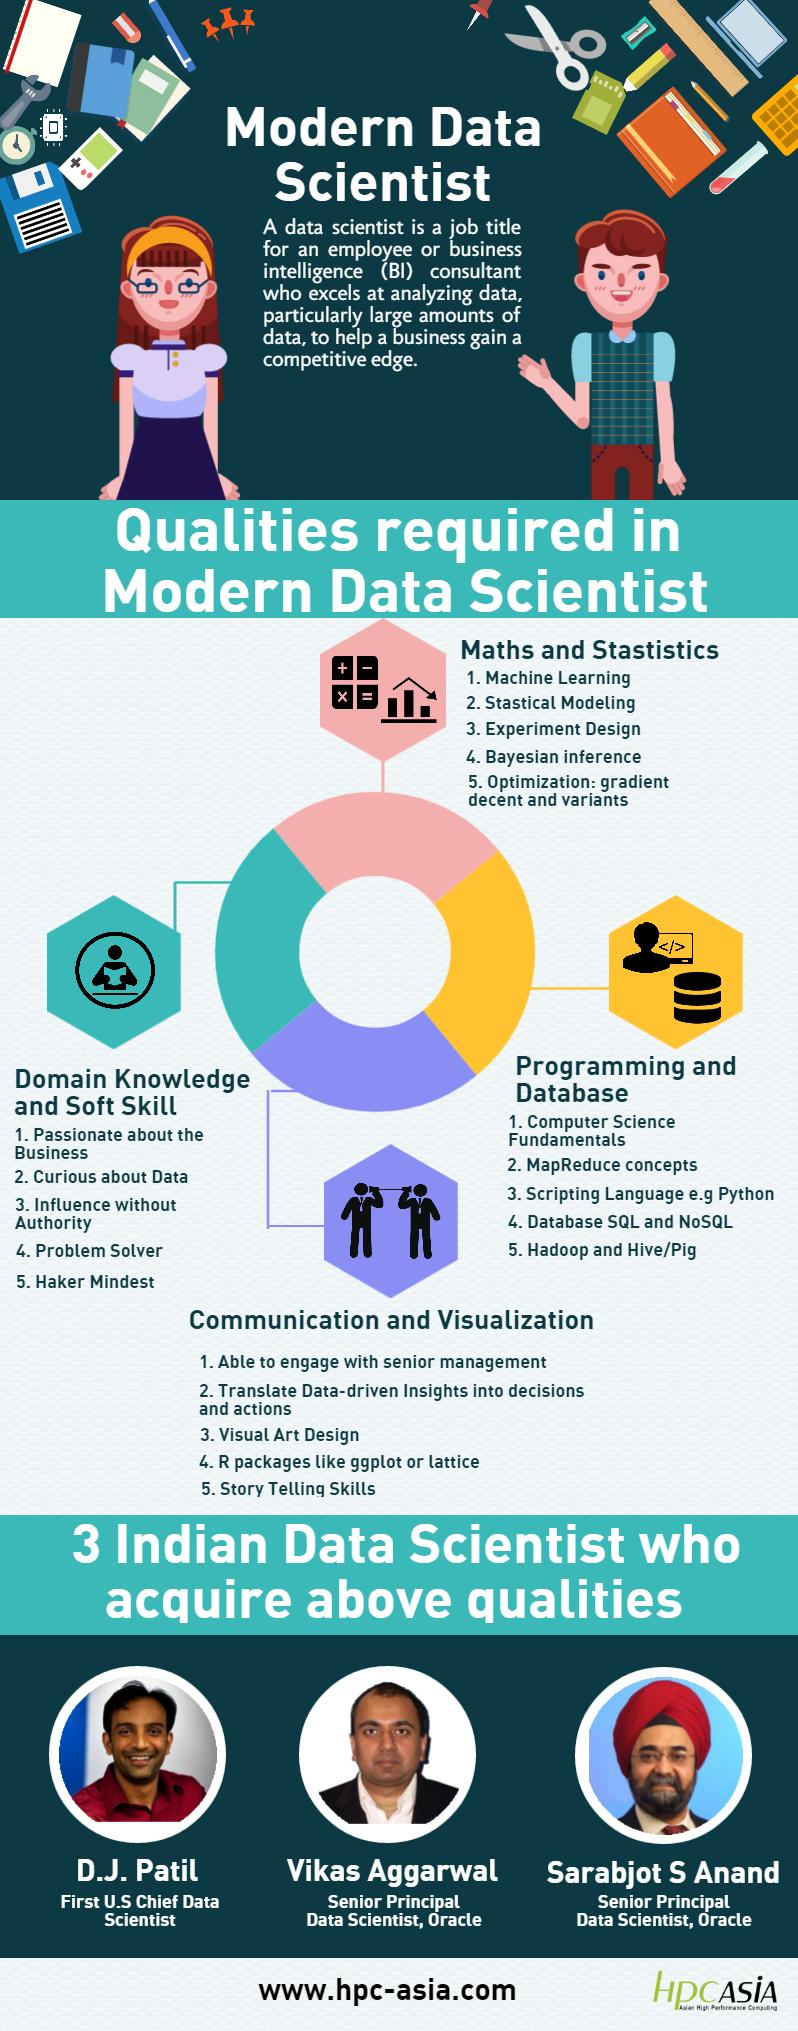Identify some key points in this picture. Hadoop is mentioned as belonging to the skill set of programming and database management. Python is considered a part of both programming and database skills. Storytelling skills are mentioned under the skill set of communication and visualization. The infographic shows four types of qualities required by a data scientist. Problem solver is mentioned under the skill set of domain knowledge and soft skills. 